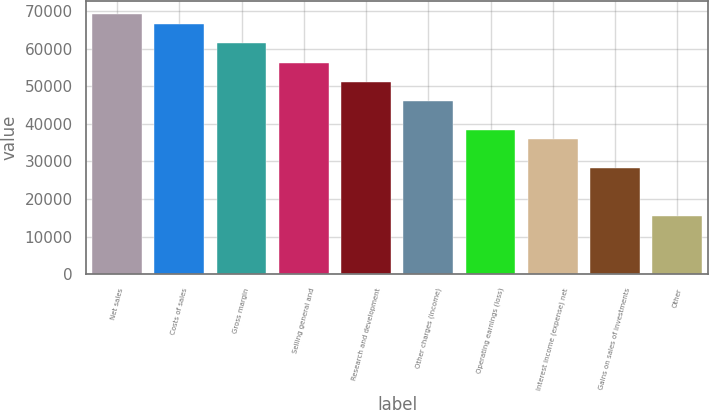Convert chart to OTSL. <chart><loc_0><loc_0><loc_500><loc_500><bar_chart><fcel>Net sales<fcel>Costs of sales<fcel>Gross margin<fcel>Selling general and<fcel>Research and development<fcel>Other charges (income)<fcel>Operating earnings (loss)<fcel>Interest income (expense) net<fcel>Gains on sales of investments<fcel>Other<nl><fcel>69128.1<fcel>66567.8<fcel>61447.2<fcel>56326.6<fcel>51206<fcel>46085.4<fcel>38404.5<fcel>35844.2<fcel>28163.3<fcel>15361.8<nl></chart> 